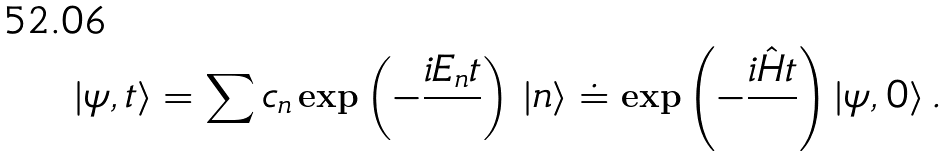Convert formula to latex. <formula><loc_0><loc_0><loc_500><loc_500>| \psi , t \rangle = \sum c _ { n } \exp \left ( - { \frac { i E _ { n } t } { } } \right ) \, | n \rangle \doteq \exp \left ( - { \frac { i \hat { H } t } { } } \right ) | \psi , 0 \rangle \, .</formula> 